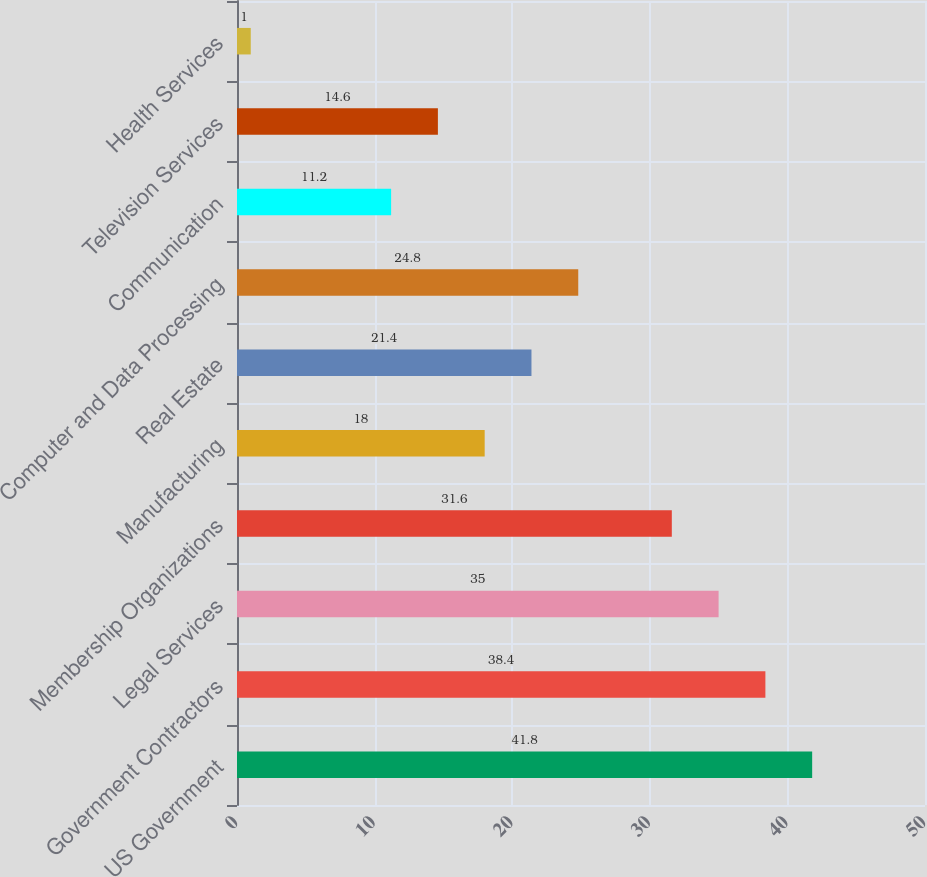Convert chart. <chart><loc_0><loc_0><loc_500><loc_500><bar_chart><fcel>US Government<fcel>Government Contractors<fcel>Legal Services<fcel>Membership Organizations<fcel>Manufacturing<fcel>Real Estate<fcel>Computer and Data Processing<fcel>Communication<fcel>Television Services<fcel>Health Services<nl><fcel>41.8<fcel>38.4<fcel>35<fcel>31.6<fcel>18<fcel>21.4<fcel>24.8<fcel>11.2<fcel>14.6<fcel>1<nl></chart> 